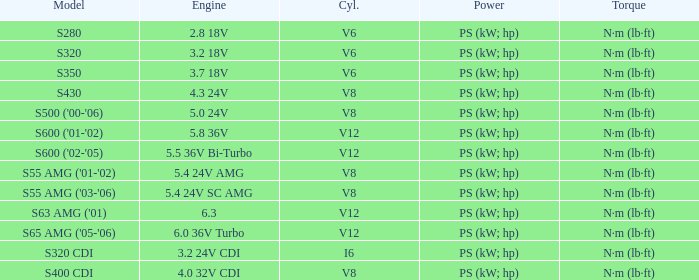Which Torque has a Model of s63 amg ('01)? N·m (lb·ft). 